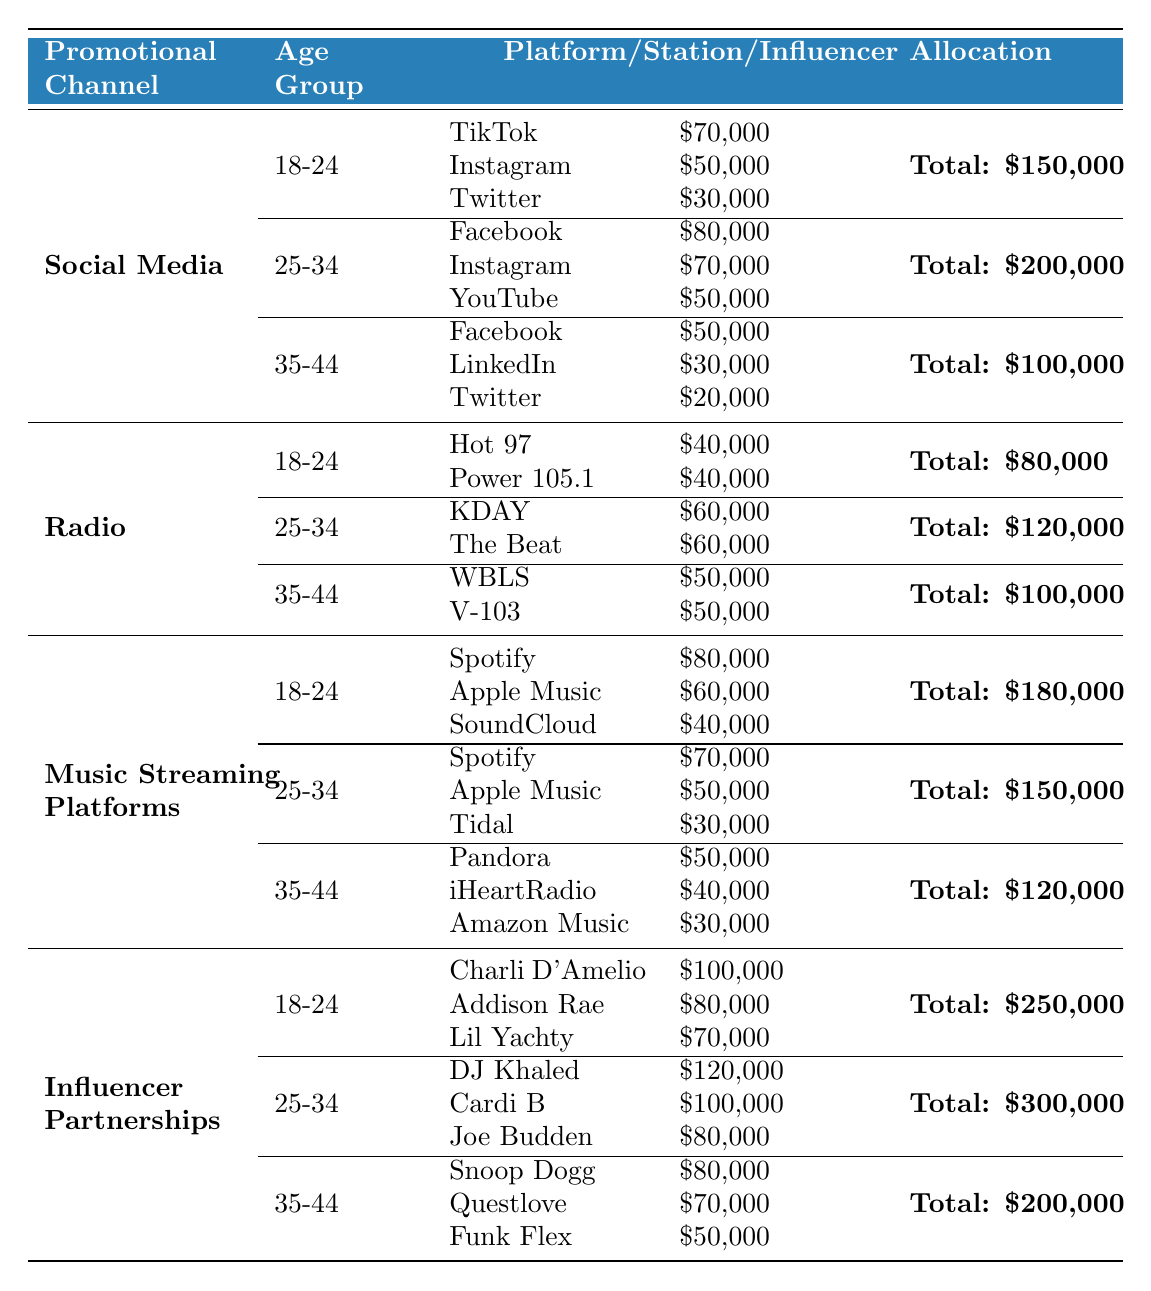What is the total budget allocated for the "Influencer Partnerships" channel for the 18-24 age group? The total budget for the 18-24 age group under "Influencer Partnerships" is mentioned in the table. It states that the total is $250,000.
Answer: $250,000 Which social media platform receives the highest allocation in the 25-34 age group? In the 25-34 age group under the "Social Media" channel, Facebook receives the highest allocation of $80,000 compared to Instagram ($70,000) and YouTube ($50,000).
Answer: Facebook What is the combined budget allocation for all platforms in the 35-44 age group under the "Music Streaming Platforms"? The total budget allocated for the 35-44 age group under "Music Streaming Platforms" is $120,000, which is the sum of the individual allocations for Pandora ($50,000), iHeartRadio ($40,000), and Amazon Music ($30,000). Therefore, $50,000 + $40,000 + $30,000 = $120,000.
Answer: $120,000 Is the budget for the 25-34 age group higher in "Radio" or "Social Media" campaigns? The budget for the 25-34 age group is $120,000 under "Radio" (KDAY and The Beat) and $200,000 under "Social Media" (Facebook, Instagram, YouTube). Since $200,000 > $120,000, it's higher in "Social Media".
Answer: Yes What is the total budget for all age groups under the "Music Streaming Platforms"? The total budget is calculated by adding the budgets of all age groups: 18-24 ($180,000) + 25-34 ($150,000) + 35-44 ($120,000) = $450,000.
Answer: $450,000 Which influencer has the lowest allocation in the 35-44 age group for "Influencer Partnerships"? In the 35-44 age group, the allocations for the influencers are Snoop Dogg ($80,000), Questlove ($70,000), and Funk Flex ($50,000). The lowest is Funk Flex with $50,000.
Answer: Funk Flex What is the average budget allocation for the 18-24 age group across all promotional channels? The budgets for the 18-24 age group in each channel are: $150,000 (Social Media), $80,000 (Radio), $180,000 (Music Streaming), and $250,000 (Influencer Partnerships). To find the average, add these up: $150,000 + $80,000 + $180,000 + $250,000 = $660,000 and divide by 4, which is $165,000.
Answer: $165,000 Do any platforms in the 18-24 age group have the same allocation across different channels? Checking the allocations: TikTok ($70,000 under Social Media), Hot 97 ($40,000 under Radio), Spotify ($80,000 under Music Streaming), and Charli D'Amelio ($100,000 under Influencer Partnerships). None of the platforms have the same allocation.
Answer: No What is the total amount allocated to Instagram across all age groups and channels? The allocations to Instagram are $50,000 (18-24 Social Media) + $70,000 (25-34 Social Media) = $120,000 and $0 in the 35-44 age group. The total is $50,000 + $70,000 = $120,000.
Answer: $120,000 Which target demographic has the largest total budget allocation across all promotional channels? To find the largest total for age groups: 18-24 ($150,000 + $80,000 + $180,000 + $250,000 = $660,000), 25-34 ($200,000 + $120,000 + $150,000 + $300,000 = $770,000), and 35-44 ($100,000 + $100,000 + $120,000 + $200,000 = $520,000). The largest total is for the 25-34 age group, totaling $770,000.
Answer: 25-34 age group 